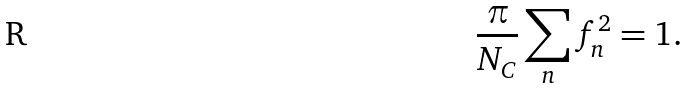Convert formula to latex. <formula><loc_0><loc_0><loc_500><loc_500>\frac { \pi } { N _ { C } } \sum _ { n } f _ { n } ^ { 2 } = 1 .</formula> 